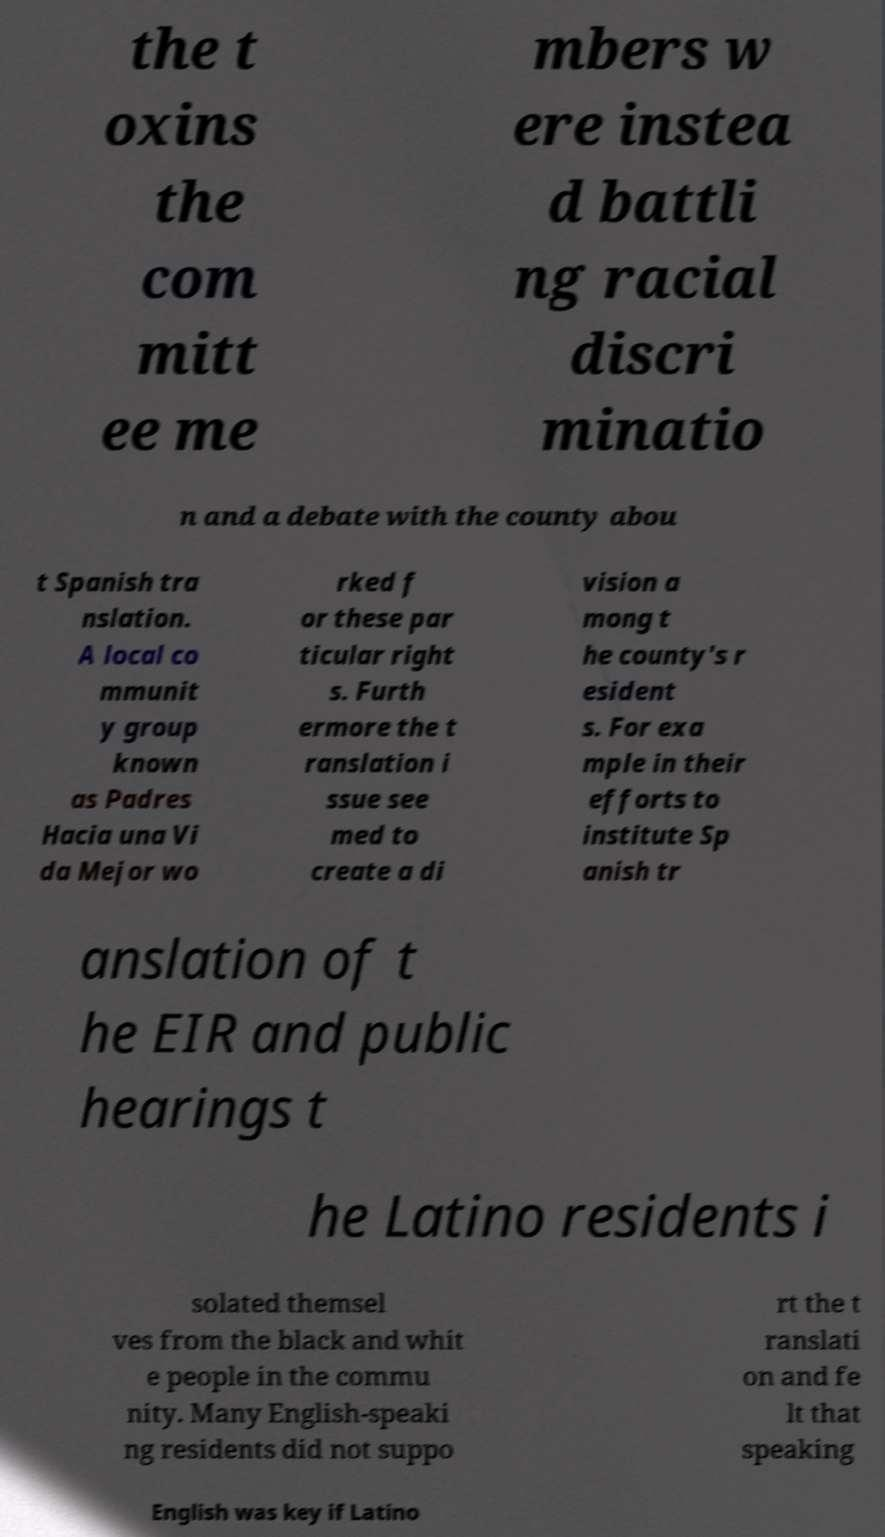Please read and relay the text visible in this image. What does it say? the t oxins the com mitt ee me mbers w ere instea d battli ng racial discri minatio n and a debate with the county abou t Spanish tra nslation. A local co mmunit y group known as Padres Hacia una Vi da Mejor wo rked f or these par ticular right s. Furth ermore the t ranslation i ssue see med to create a di vision a mong t he county's r esident s. For exa mple in their efforts to institute Sp anish tr anslation of t he EIR and public hearings t he Latino residents i solated themsel ves from the black and whit e people in the commu nity. Many English-speaki ng residents did not suppo rt the t ranslati on and fe lt that speaking English was key if Latino 